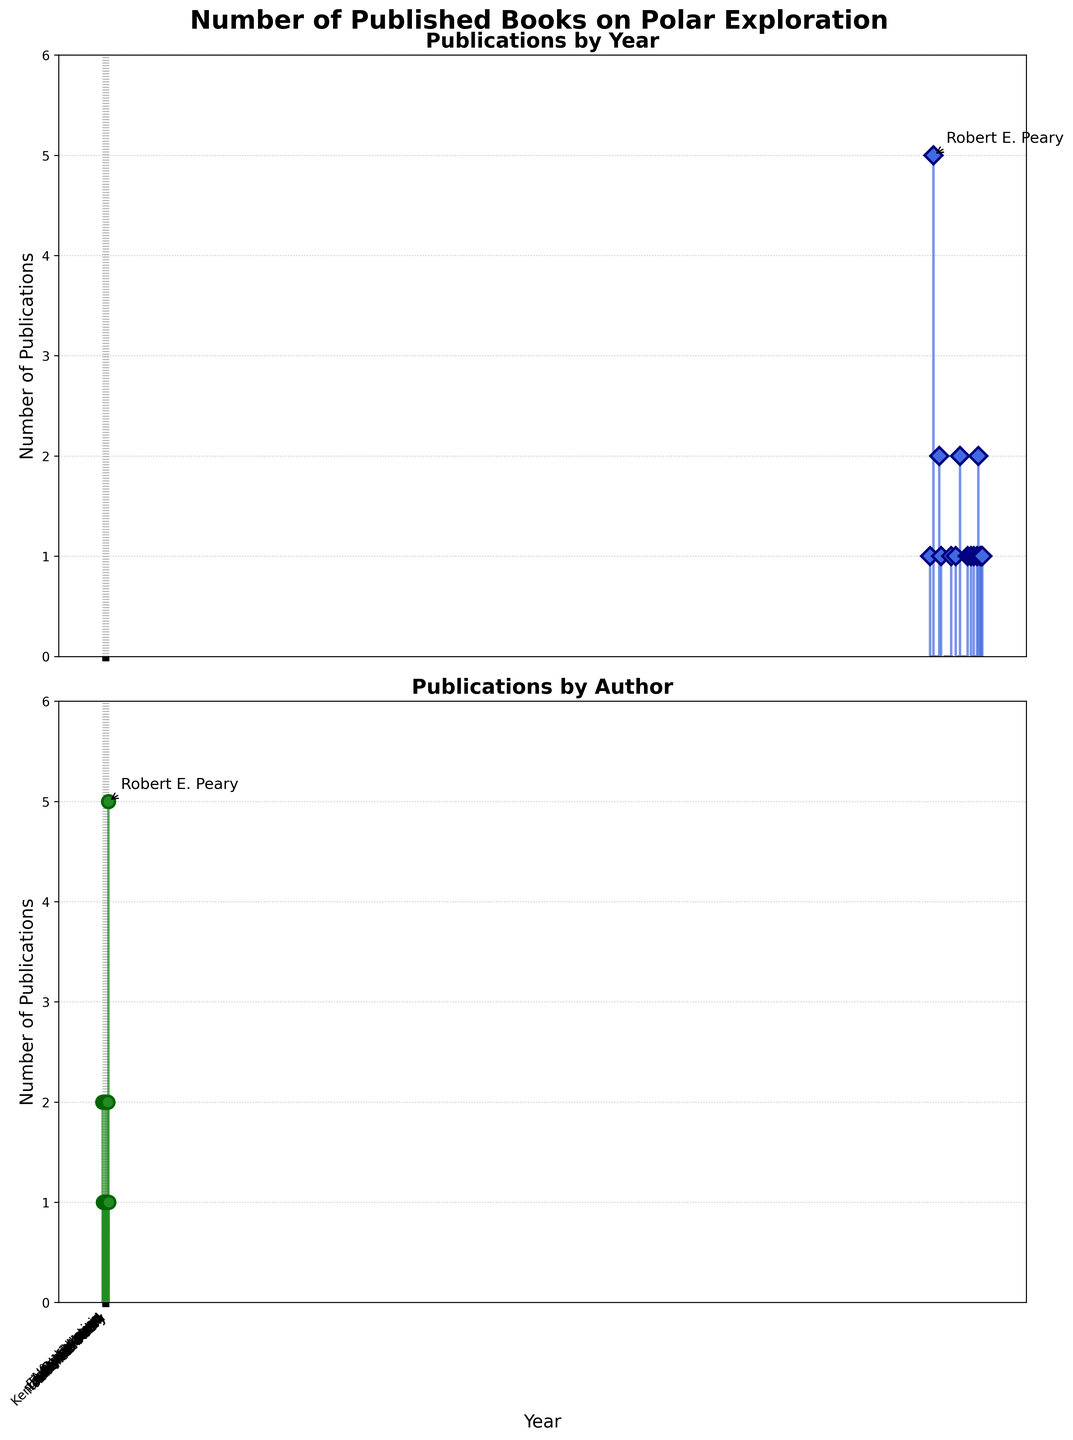How many books on polar exploration were published by Fridtjof Nansen in 1900? Look at the first point on the first subplot showing publications by year. There is a single stem at 1900 with a label "1".
Answer: 1 Which year had the highest number of book publications on polar exploration? Examine the first subplot for the highest stem. The highest stem corresponds to the year 1908 with a value of 5.
Answer: 1908 How many authors are shown in the figure? Count the number of authors listed on the x-axis of the second subplot. There are 15 authors.
Answer: 15 Comparing Robert E. Peary and Roald Amundsen, who had more publications? Refer to the second subplot. Robert E. Peary has a higher number of publications indicated by a taller stem compared to Roald Amundsen.
Answer: Robert E. Peary What is the total number of polar exploration books published according to the data presented? Sum all the values of the stems in the first subplot. The total is 1 + 5 + 2 + 1 + 1 + 1 + 2 + 1 + 1 + 1 + 1 + 2 + 1 + 1 + 1 = 22.
Answer: 22 Between 1920 and 1970, which author published the most books on polar exploration? Look at the first subplot between the years 1920 and 1970. Roald Amundsen in 1921 and Gareth Wood in 1969 each published two books.
Answer: Roald Amundsen and Gareth Wood What is the total number of books published by Robert E. Peary? Look at the second subplot and find the stem labeled with 'Robert E. Peary'. The height of the stem is 5.
Answer: 5 What is the sum of publications from the year 2000 to 2020? Sum the values from the first subplot for years 2000, 2008, 2011, 2015, 2017, and 2020. This is 1 + 1 + 2 + 1 + 1 + 1 = 7.
Answer: 7 Which author published a book titled 'To the End of the Earth'? This can be inferred from the x-axis label in the second subplot showing a higher stem. The data indicates that Tom Avery published "To the End of the Earth" in 2008.
Answer: Tom Avery How many books did Peter Freuchen publish? Refer to the second subplot. Find the author "Peter Freuchen". There is a single stem with the value 1.
Answer: 1 